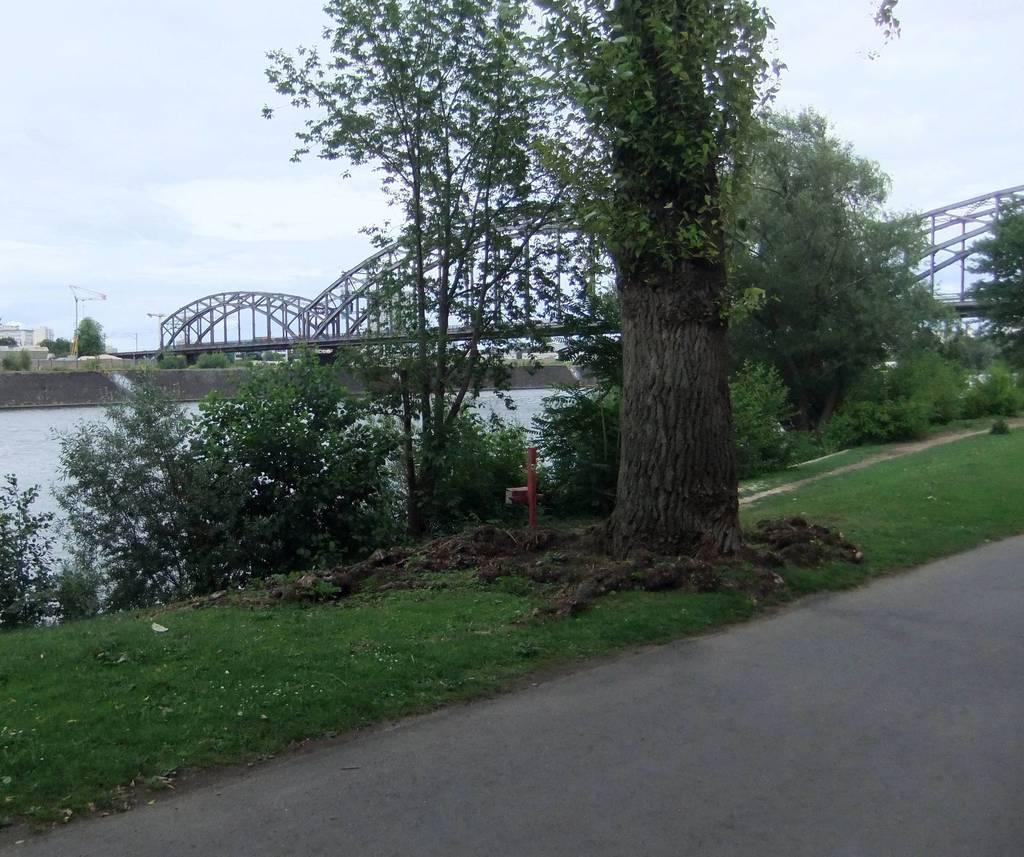Could you give a brief overview of what you see in this image? In this image we can see a group of trees, a pole and grass. In the foreground we can see the pathway. In the center of the image we can see a bridge and water. On the left side of the image we can see a building and some poles. At the top of the image we can see the sky. 